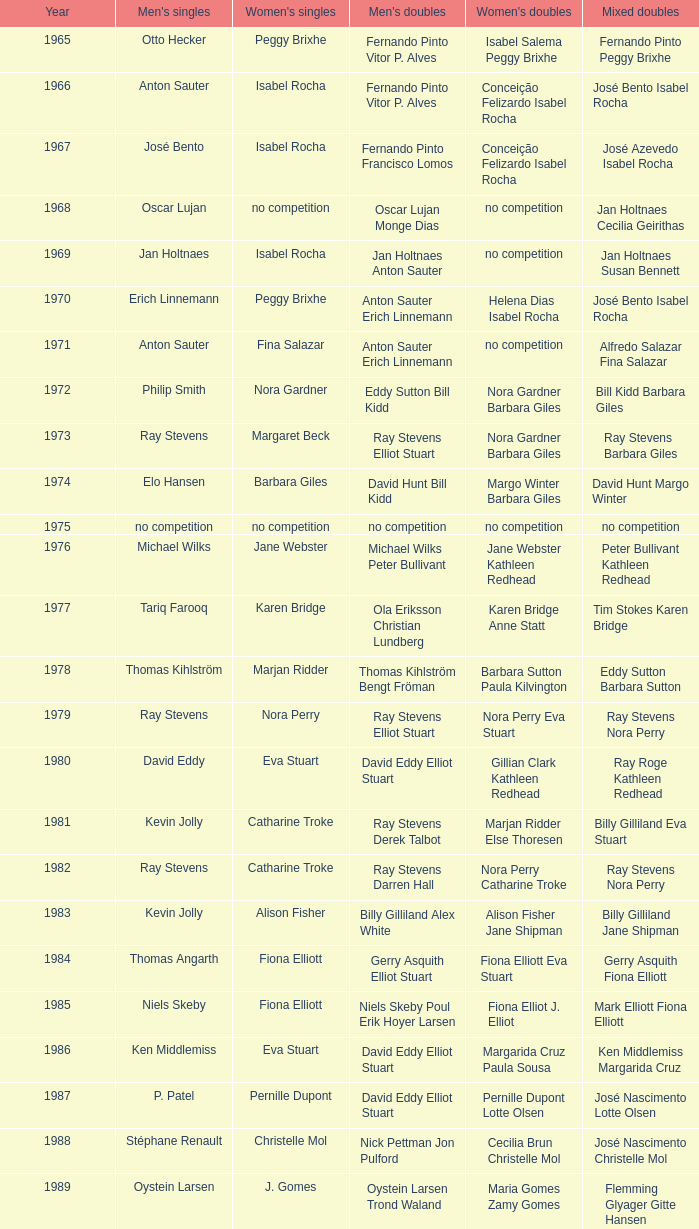Which women's doubles happened after 1987 and a women's single of astrid van der knaap? Elena Denisova Marina Yakusheva. 